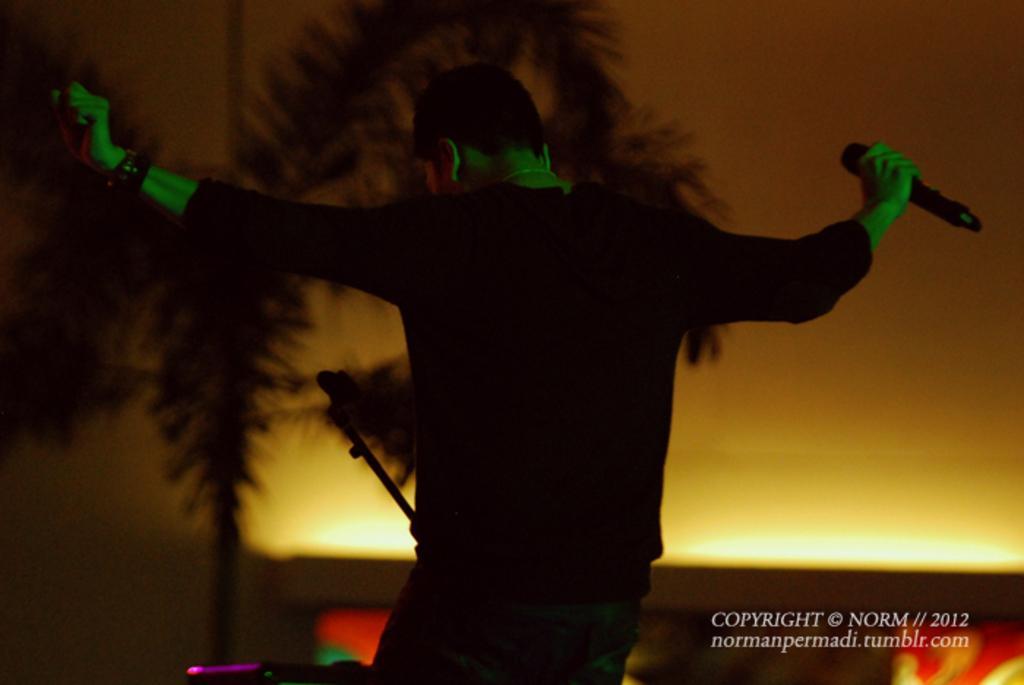Please provide a concise description of this image. In this image I can see a person wearing black colored dress is standing and holding a black colored microphone in his hand. In the background I can see a tree and the orange colored surface. 